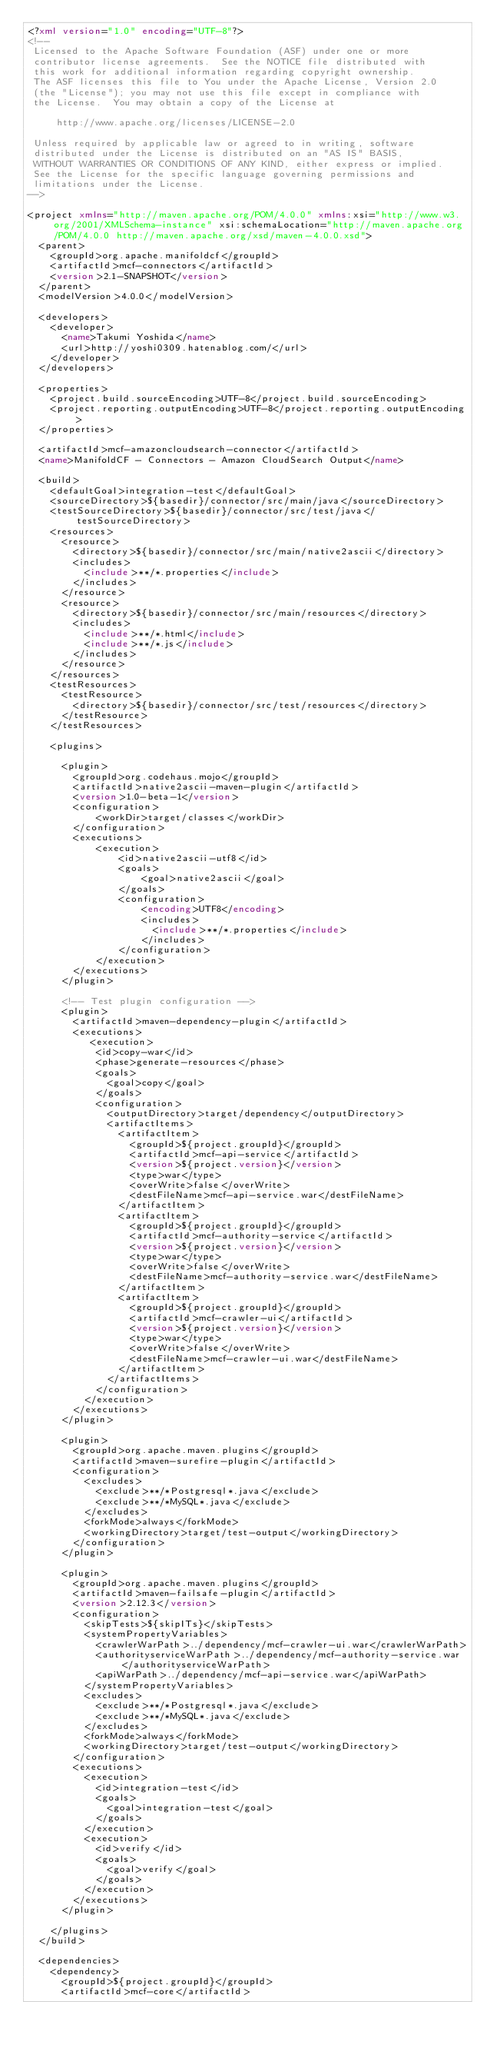<code> <loc_0><loc_0><loc_500><loc_500><_XML_><?xml version="1.0" encoding="UTF-8"?>
<!--
 Licensed to the Apache Software Foundation (ASF) under one or more
 contributor license agreements.  See the NOTICE file distributed with
 this work for additional information regarding copyright ownership.
 The ASF licenses this file to You under the Apache License, Version 2.0
 (the "License"); you may not use this file except in compliance with
 the License.  You may obtain a copy of the License at

     http://www.apache.org/licenses/LICENSE-2.0

 Unless required by applicable law or agreed to in writing, software
 distributed under the License is distributed on an "AS IS" BASIS,
 WITHOUT WARRANTIES OR CONDITIONS OF ANY KIND, either express or implied.
 See the License for the specific language governing permissions and
 limitations under the License.
-->

<project xmlns="http://maven.apache.org/POM/4.0.0" xmlns:xsi="http://www.w3.org/2001/XMLSchema-instance" xsi:schemaLocation="http://maven.apache.org/POM/4.0.0 http://maven.apache.org/xsd/maven-4.0.0.xsd">
  <parent>
    <groupId>org.apache.manifoldcf</groupId>
    <artifactId>mcf-connectors</artifactId>
    <version>2.1-SNAPSHOT</version>
  </parent>
  <modelVersion>4.0.0</modelVersion>

  <developers>
    <developer>
      <name>Takumi Yoshida</name>
      <url>http://yoshi0309.hatenablog.com/</url>
    </developer>
  </developers>

  <properties>
    <project.build.sourceEncoding>UTF-8</project.build.sourceEncoding>
    <project.reporting.outputEncoding>UTF-8</project.reporting.outputEncoding>
  </properties>

  <artifactId>mcf-amazoncloudsearch-connector</artifactId>
  <name>ManifoldCF - Connectors - Amazon CloudSearch Output</name>

  <build>
    <defaultGoal>integration-test</defaultGoal>
    <sourceDirectory>${basedir}/connector/src/main/java</sourceDirectory>
    <testSourceDirectory>${basedir}/connector/src/test/java</testSourceDirectory>
    <resources>
      <resource>
        <directory>${basedir}/connector/src/main/native2ascii</directory>
        <includes>
          <include>**/*.properties</include>
        </includes>
      </resource>
      <resource>
        <directory>${basedir}/connector/src/main/resources</directory>
        <includes>
          <include>**/*.html</include>
          <include>**/*.js</include>
        </includes>
      </resource>
    </resources> 
    <testResources>
      <testResource>
        <directory>${basedir}/connector/src/test/resources</directory>
      </testResource>
    </testResources>

    <plugins>

      <plugin>
        <groupId>org.codehaus.mojo</groupId>
        <artifactId>native2ascii-maven-plugin</artifactId>
        <version>1.0-beta-1</version>
        <configuration>
            <workDir>target/classes</workDir>
        </configuration>
        <executions>
            <execution>
                <id>native2ascii-utf8</id>
                <goals>
                    <goal>native2ascii</goal>
                </goals>
                <configuration>
                    <encoding>UTF8</encoding>
                    <includes>
                      <include>**/*.properties</include>
                    </includes>
                </configuration>
            </execution>
        </executions>
      </plugin>

      <!-- Test plugin configuration -->
      <plugin>
        <artifactId>maven-dependency-plugin</artifactId>
        <executions>
           <execution>
            <id>copy-war</id>
            <phase>generate-resources</phase>
            <goals>
              <goal>copy</goal>
            </goals>
            <configuration>
              <outputDirectory>target/dependency</outputDirectory>
              <artifactItems>
                <artifactItem>
                  <groupId>${project.groupId}</groupId>
                  <artifactId>mcf-api-service</artifactId>
                  <version>${project.version}</version>
                  <type>war</type>
                  <overWrite>false</overWrite>
                  <destFileName>mcf-api-service.war</destFileName>
                </artifactItem>
                <artifactItem>
                  <groupId>${project.groupId}</groupId>
                  <artifactId>mcf-authority-service</artifactId>
                  <version>${project.version}</version>
                  <type>war</type>
                  <overWrite>false</overWrite>
                  <destFileName>mcf-authority-service.war</destFileName>
                </artifactItem>
                <artifactItem>
                  <groupId>${project.groupId}</groupId>
                  <artifactId>mcf-crawler-ui</artifactId>
                  <version>${project.version}</version>
                  <type>war</type>
                  <overWrite>false</overWrite>
                  <destFileName>mcf-crawler-ui.war</destFileName>
                </artifactItem>
              </artifactItems>
            </configuration>
          </execution>
        </executions>
      </plugin>

      <plugin>
        <groupId>org.apache.maven.plugins</groupId>
        <artifactId>maven-surefire-plugin</artifactId>
        <configuration>
          <excludes>
            <exclude>**/*Postgresql*.java</exclude>
            <exclude>**/*MySQL*.java</exclude>
          </excludes>
          <forkMode>always</forkMode>
          <workingDirectory>target/test-output</workingDirectory>
        </configuration>
      </plugin>

      <plugin>
        <groupId>org.apache.maven.plugins</groupId>
        <artifactId>maven-failsafe-plugin</artifactId>
        <version>2.12.3</version>
        <configuration>
          <skipTests>${skipITs}</skipTests>
          <systemPropertyVariables>
            <crawlerWarPath>../dependency/mcf-crawler-ui.war</crawlerWarPath>
            <authorityserviceWarPath>../dependency/mcf-authority-service.war</authorityserviceWarPath>
            <apiWarPath>../dependency/mcf-api-service.war</apiWarPath>
          </systemPropertyVariables>
          <excludes>
            <exclude>**/*Postgresql*.java</exclude>
            <exclude>**/*MySQL*.java</exclude>
          </excludes>
          <forkMode>always</forkMode>
          <workingDirectory>target/test-output</workingDirectory>
        </configuration>
        <executions>
          <execution>
            <id>integration-test</id>
            <goals>
              <goal>integration-test</goal>
            </goals>
          </execution>
          <execution>
            <id>verify</id>
            <goals>
              <goal>verify</goal>
            </goals>
          </execution>
        </executions>
      </plugin>

    </plugins>
  </build>
  
  <dependencies>
    <dependency>
      <groupId>${project.groupId}</groupId>
      <artifactId>mcf-core</artifactId></code> 